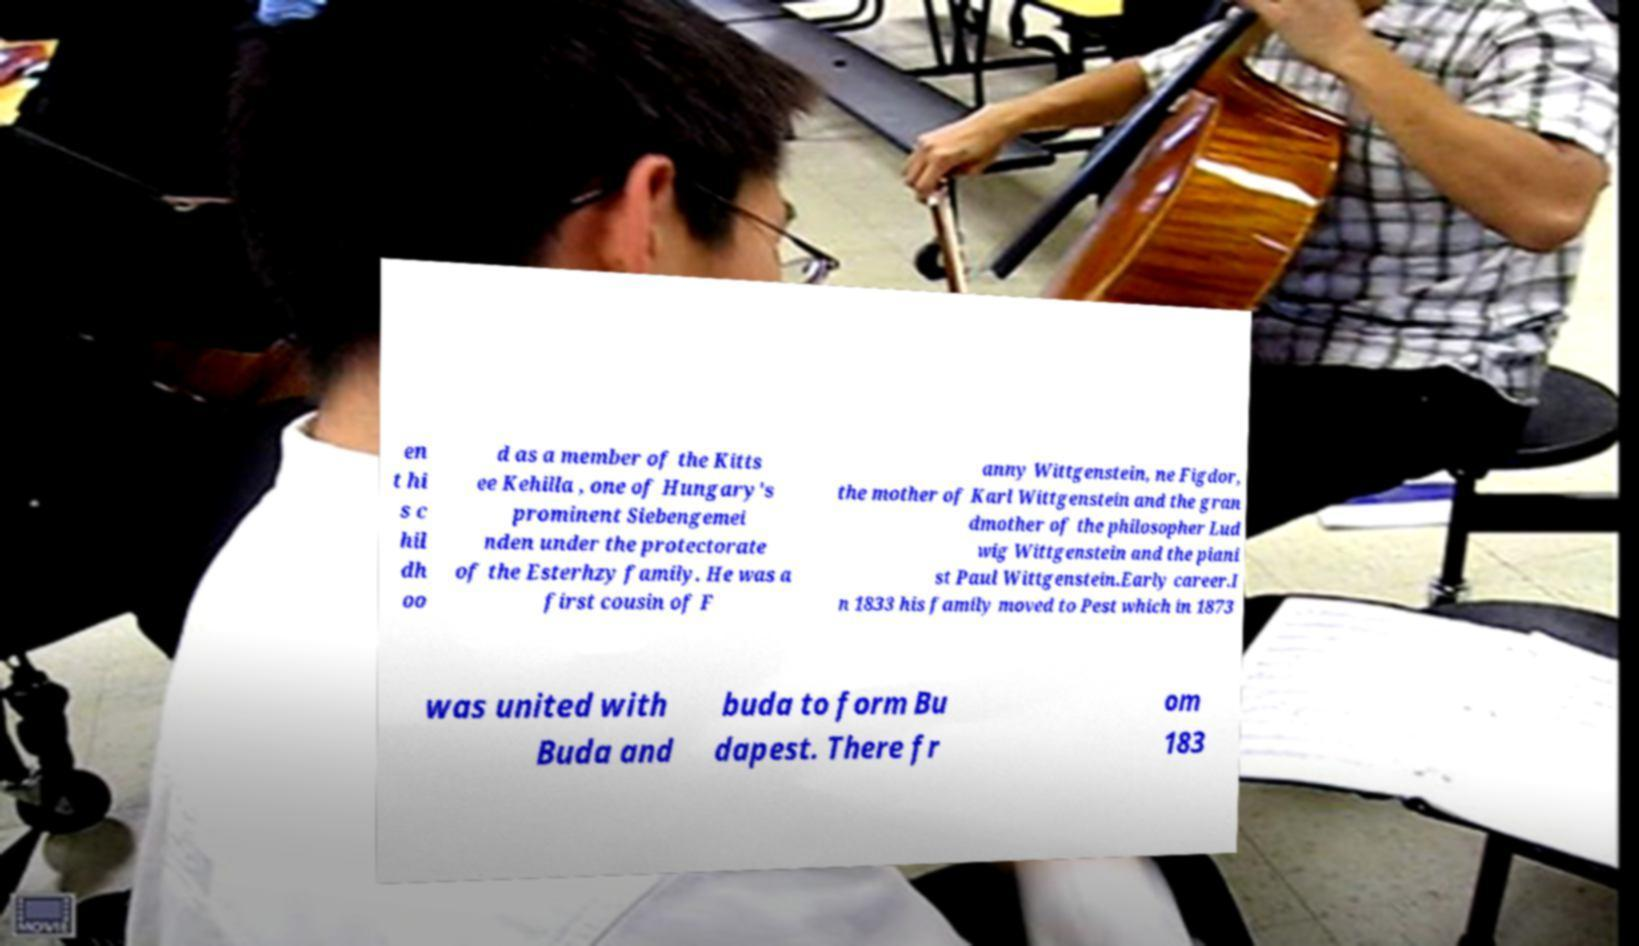For documentation purposes, I need the text within this image transcribed. Could you provide that? en t hi s c hil dh oo d as a member of the Kitts ee Kehilla , one of Hungary's prominent Siebengemei nden under the protectorate of the Esterhzy family. He was a first cousin of F anny Wittgenstein, ne Figdor, the mother of Karl Wittgenstein and the gran dmother of the philosopher Lud wig Wittgenstein and the piani st Paul Wittgenstein.Early career.I n 1833 his family moved to Pest which in 1873 was united with Buda and buda to form Bu dapest. There fr om 183 